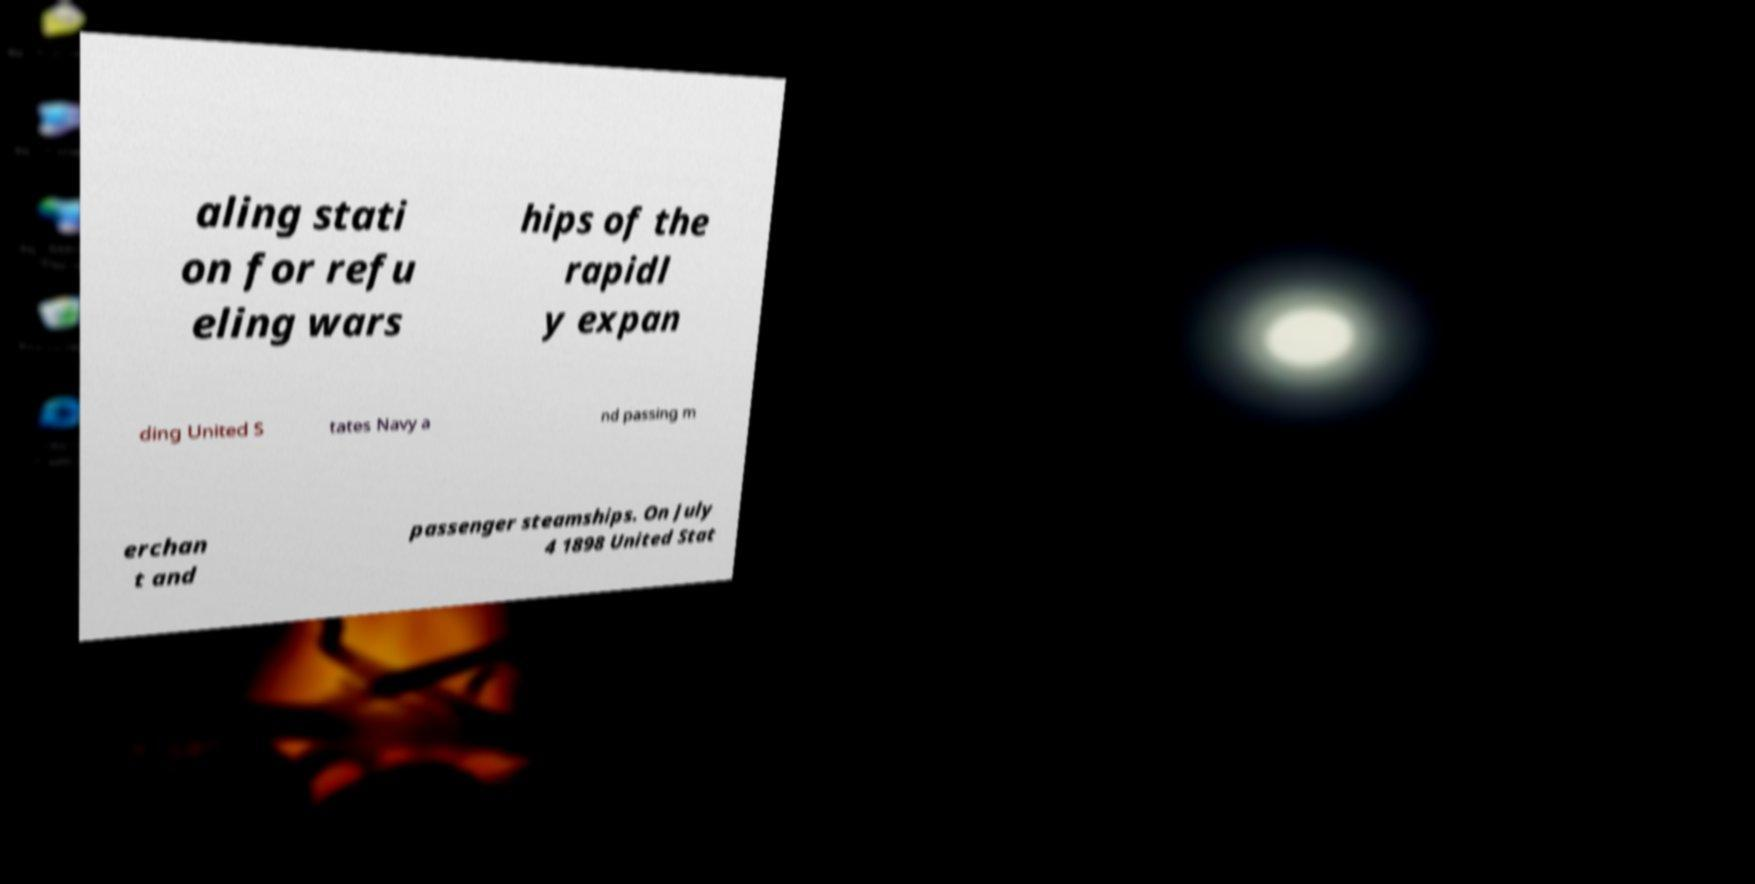For documentation purposes, I need the text within this image transcribed. Could you provide that? aling stati on for refu eling wars hips of the rapidl y expan ding United S tates Navy a nd passing m erchan t and passenger steamships. On July 4 1898 United Stat 